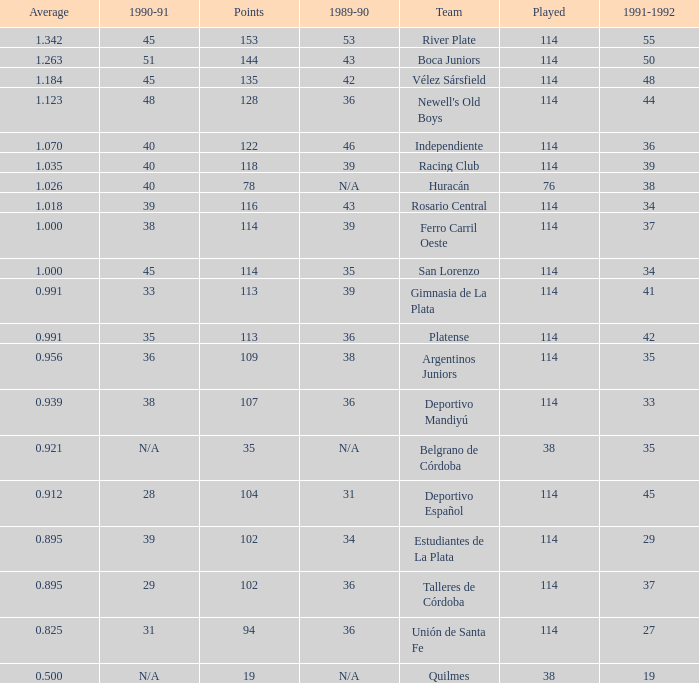Parse the table in full. {'header': ['Average', '1990-91', 'Points', '1989-90', 'Team', 'Played', '1991-1992'], 'rows': [['1.342', '45', '153', '53', 'River Plate', '114', '55'], ['1.263', '51', '144', '43', 'Boca Juniors', '114', '50'], ['1.184', '45', '135', '42', 'Vélez Sársfield', '114', '48'], ['1.123', '48', '128', '36', "Newell's Old Boys", '114', '44'], ['1.070', '40', '122', '46', 'Independiente', '114', '36'], ['1.035', '40', '118', '39', 'Racing Club', '114', '39'], ['1.026', '40', '78', 'N/A', 'Huracán', '76', '38'], ['1.018', '39', '116', '43', 'Rosario Central', '114', '34'], ['1.000', '38', '114', '39', 'Ferro Carril Oeste', '114', '37'], ['1.000', '45', '114', '35', 'San Lorenzo', '114', '34'], ['0.991', '33', '113', '39', 'Gimnasia de La Plata', '114', '41'], ['0.991', '35', '113', '36', 'Platense', '114', '42'], ['0.956', '36', '109', '38', 'Argentinos Juniors', '114', '35'], ['0.939', '38', '107', '36', 'Deportivo Mandiyú', '114', '33'], ['0.921', 'N/A', '35', 'N/A', 'Belgrano de Córdoba', '38', '35'], ['0.912', '28', '104', '31', 'Deportivo Español', '114', '45'], ['0.895', '39', '102', '34', 'Estudiantes de La Plata', '114', '29'], ['0.895', '29', '102', '36', 'Talleres de Córdoba', '114', '37'], ['0.825', '31', '94', '36', 'Unión de Santa Fe', '114', '27'], ['0.500', 'N/A', '19', 'N/A', 'Quilmes', '38', '19']]} How much 1991-1992 has a 1989-90 of 36, and an Average of 0.8250000000000001? 0.0. 